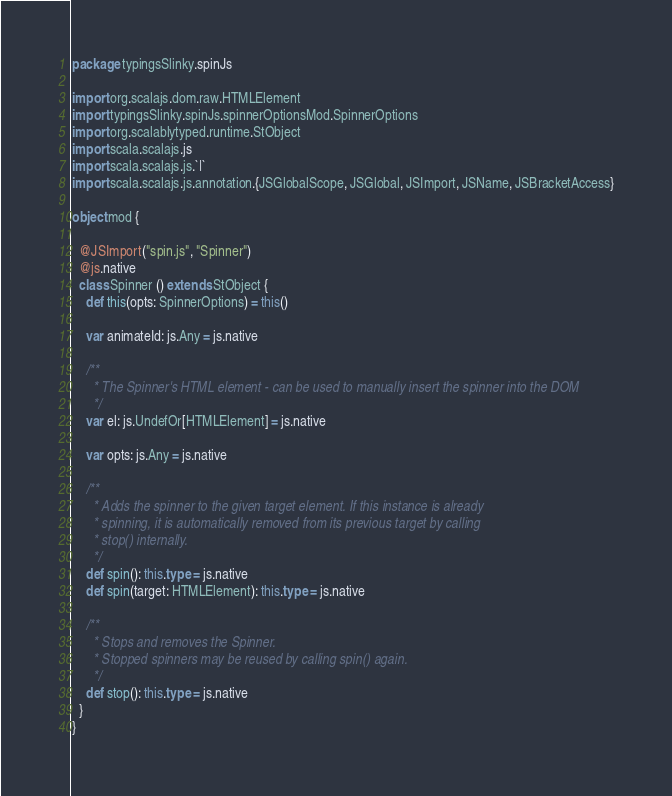<code> <loc_0><loc_0><loc_500><loc_500><_Scala_>package typingsSlinky.spinJs

import org.scalajs.dom.raw.HTMLElement
import typingsSlinky.spinJs.spinnerOptionsMod.SpinnerOptions
import org.scalablytyped.runtime.StObject
import scala.scalajs.js
import scala.scalajs.js.`|`
import scala.scalajs.js.annotation.{JSGlobalScope, JSGlobal, JSImport, JSName, JSBracketAccess}

object mod {
  
  @JSImport("spin.js", "Spinner")
  @js.native
  class Spinner () extends StObject {
    def this(opts: SpinnerOptions) = this()
    
    var animateId: js.Any = js.native
    
    /**
      * The Spinner's HTML element - can be used to manually insert the spinner into the DOM
      */
    var el: js.UndefOr[HTMLElement] = js.native
    
    var opts: js.Any = js.native
    
    /**
      * Adds the spinner to the given target element. If this instance is already
      * spinning, it is automatically removed from its previous target by calling
      * stop() internally.
      */
    def spin(): this.type = js.native
    def spin(target: HTMLElement): this.type = js.native
    
    /**
      * Stops and removes the Spinner.
      * Stopped spinners may be reused by calling spin() again.
      */
    def stop(): this.type = js.native
  }
}
</code> 